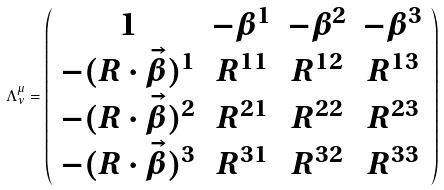Convert formula to latex. <formula><loc_0><loc_0><loc_500><loc_500>\Lambda ^ { \mu } _ { \nu } = \left ( \begin{array} { c c c c } 1 & - \beta ^ { 1 } & - \beta ^ { 2 } & - \beta ^ { 3 } \\ - ( R \cdot { \vec { \beta } } ) ^ { 1 } & R ^ { 1 1 } & R ^ { 1 2 } & R ^ { 1 3 } \\ - ( R \cdot { \vec { \beta } } ) ^ { 2 } & R ^ { 2 1 } & R ^ { 2 2 } & R ^ { 2 3 } \\ - ( R \cdot { \vec { \beta } } ) ^ { 3 } & R ^ { 3 1 } & R ^ { 3 2 } & R ^ { 3 3 } \\ \end{array} \right )</formula> 